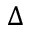<formula> <loc_0><loc_0><loc_500><loc_500>\Delta</formula> 